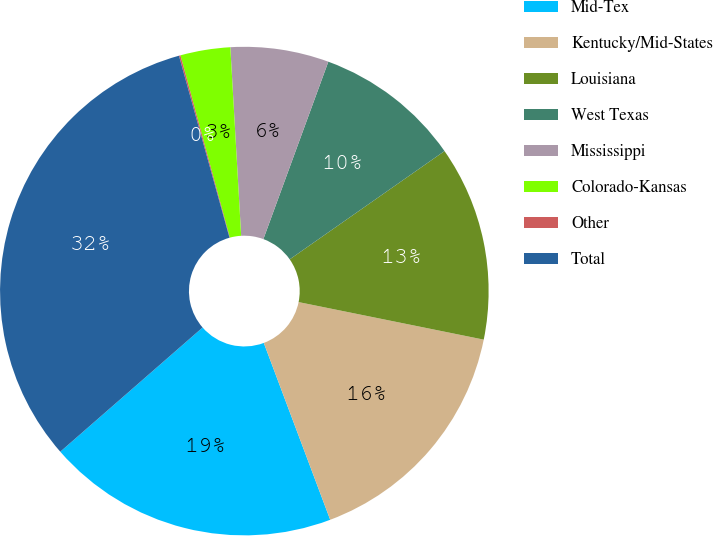Convert chart. <chart><loc_0><loc_0><loc_500><loc_500><pie_chart><fcel>Mid-Tex<fcel>Kentucky/Mid-States<fcel>Louisiana<fcel>West Texas<fcel>Mississippi<fcel>Colorado-Kansas<fcel>Other<fcel>Total<nl><fcel>19.3%<fcel>16.1%<fcel>12.9%<fcel>9.7%<fcel>6.5%<fcel>3.3%<fcel>0.1%<fcel>32.11%<nl></chart> 